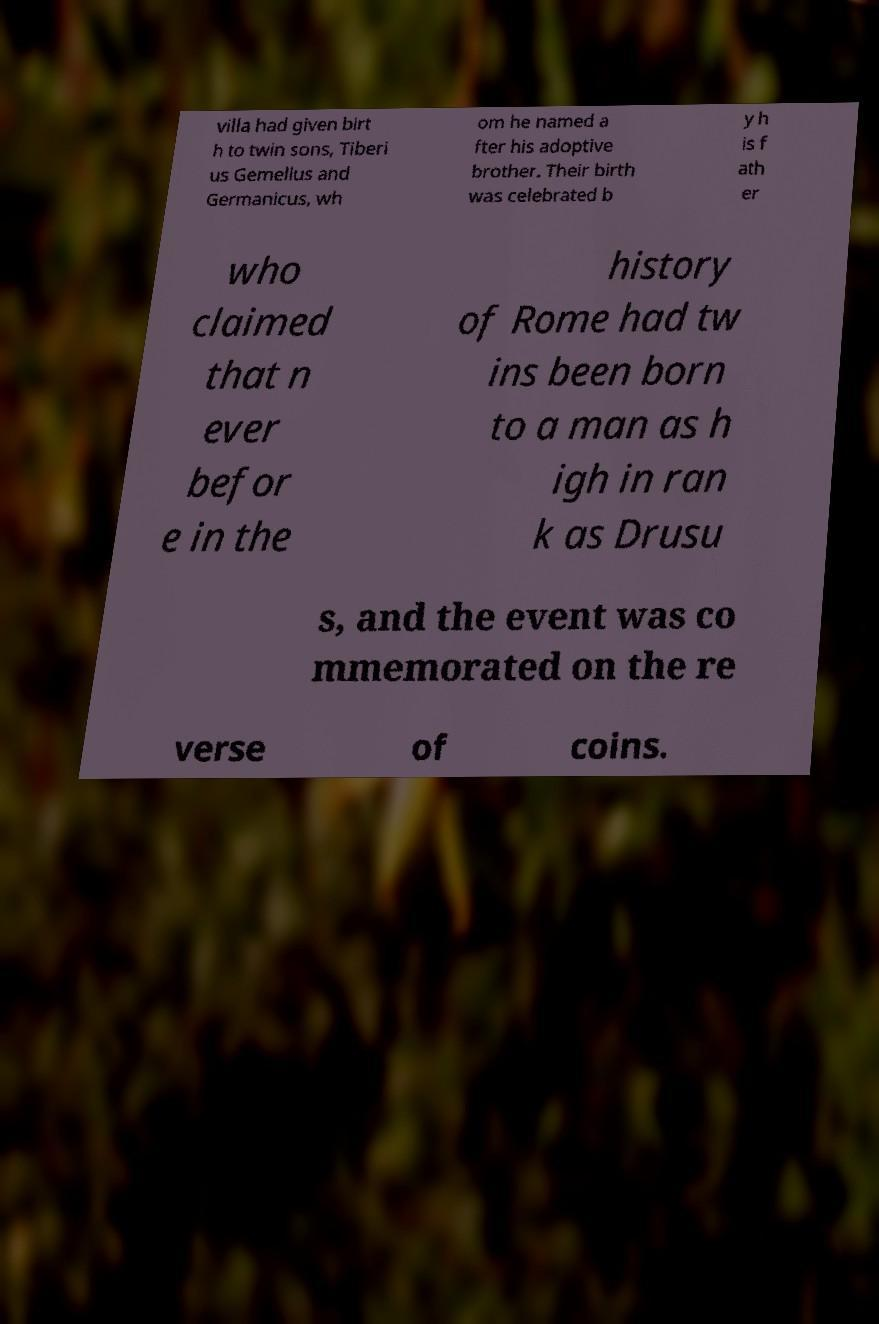Could you extract and type out the text from this image? villa had given birt h to twin sons, Tiberi us Gemellus and Germanicus, wh om he named a fter his adoptive brother. Their birth was celebrated b y h is f ath er who claimed that n ever befor e in the history of Rome had tw ins been born to a man as h igh in ran k as Drusu s, and the event was co mmemorated on the re verse of coins. 